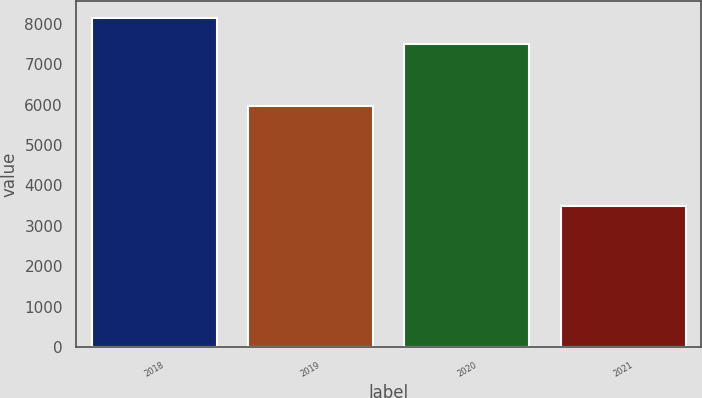Convert chart to OTSL. <chart><loc_0><loc_0><loc_500><loc_500><bar_chart><fcel>2018<fcel>2019<fcel>2020<fcel>2021<nl><fcel>8156<fcel>5975<fcel>7495<fcel>3497<nl></chart> 